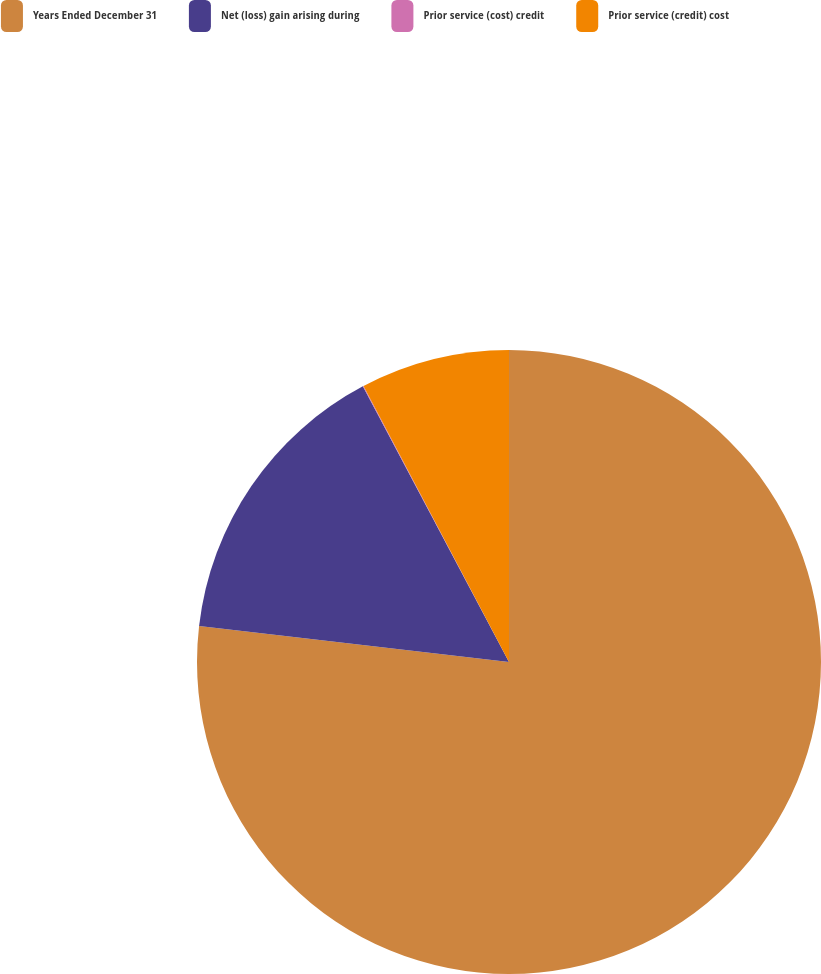<chart> <loc_0><loc_0><loc_500><loc_500><pie_chart><fcel>Years Ended December 31<fcel>Net (loss) gain arising during<fcel>Prior service (cost) credit<fcel>Prior service (credit) cost<nl><fcel>76.84%<fcel>15.4%<fcel>0.04%<fcel>7.72%<nl></chart> 